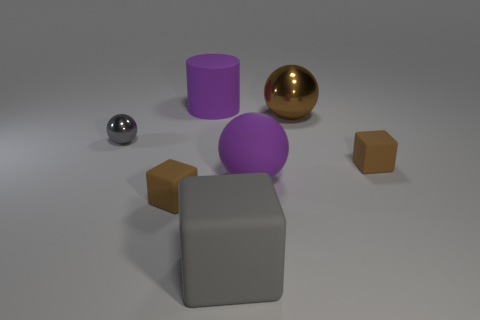What number of other small metal things have the same shape as the gray shiny thing?
Keep it short and to the point. 0. Is the tiny gray thing the same shape as the brown metallic thing?
Provide a short and direct response. Yes. How big is the gray sphere?
Keep it short and to the point. Small. How many rubber things are the same size as the gray block?
Offer a very short reply. 2. There is a metallic sphere that is right of the gray matte object; is it the same size as the purple matte ball that is right of the big gray object?
Make the answer very short. Yes. There is a big purple thing behind the small gray shiny sphere; what is its shape?
Ensure brevity in your answer.  Cylinder. There is a tiny thing to the left of the brown cube to the left of the brown metallic thing; what is it made of?
Your response must be concise. Metal. Is there a matte thing of the same color as the big cylinder?
Make the answer very short. Yes. There is a purple rubber ball; is it the same size as the metal ball that is to the right of the big cylinder?
Ensure brevity in your answer.  Yes. There is a small brown cube behind the brown object that is in front of the big purple sphere; how many small gray things are behind it?
Give a very brief answer. 1. 